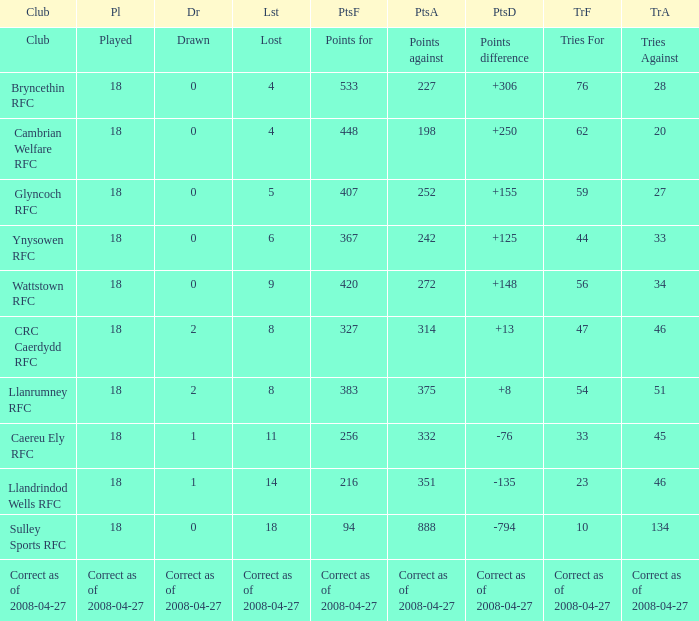What is the value of the item "Points" when the value of the item "Points against" is 272? 420.0. 